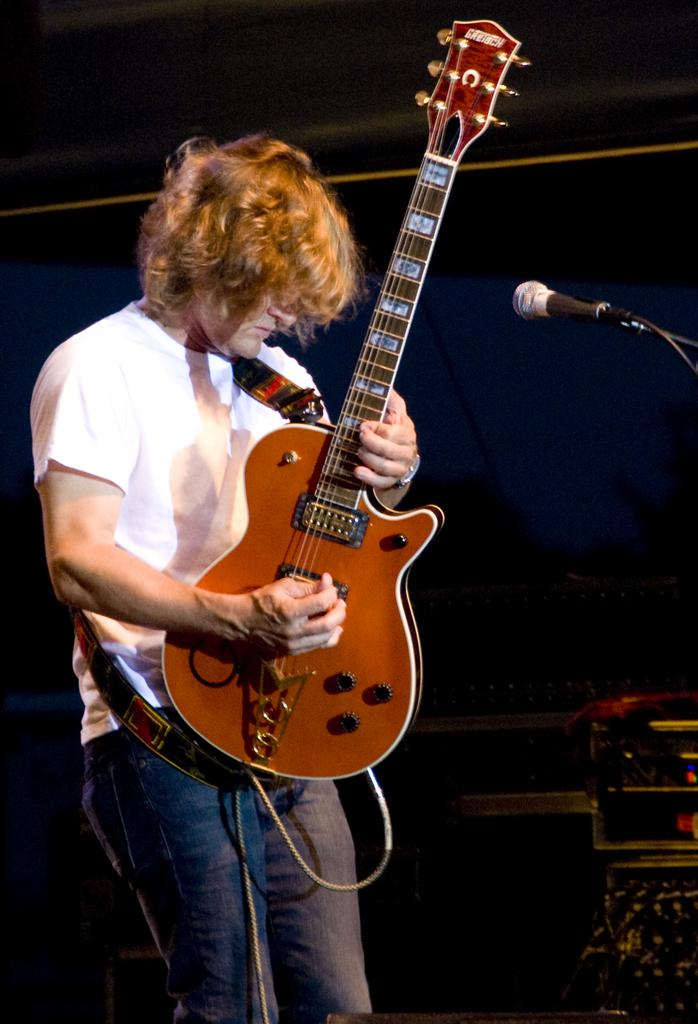What is the man in the image doing? The man is playing a guitar in the image. How is the man holding the guitar? The man is holding the guitar in his hands. What is the man standing in front of? The man is standing in front of a microphone. What is the man wearing on his upper body? The man is wearing a white t-shirt. What is the man wearing on his lower body? The man is wearing jeans. What color is the sky in the image? There is no sky visible in the image; it is focused on the man playing the guitar. What type of shirt is the man wearing in the image? The man is wearing a white t-shirt, as mentioned in the facts. 